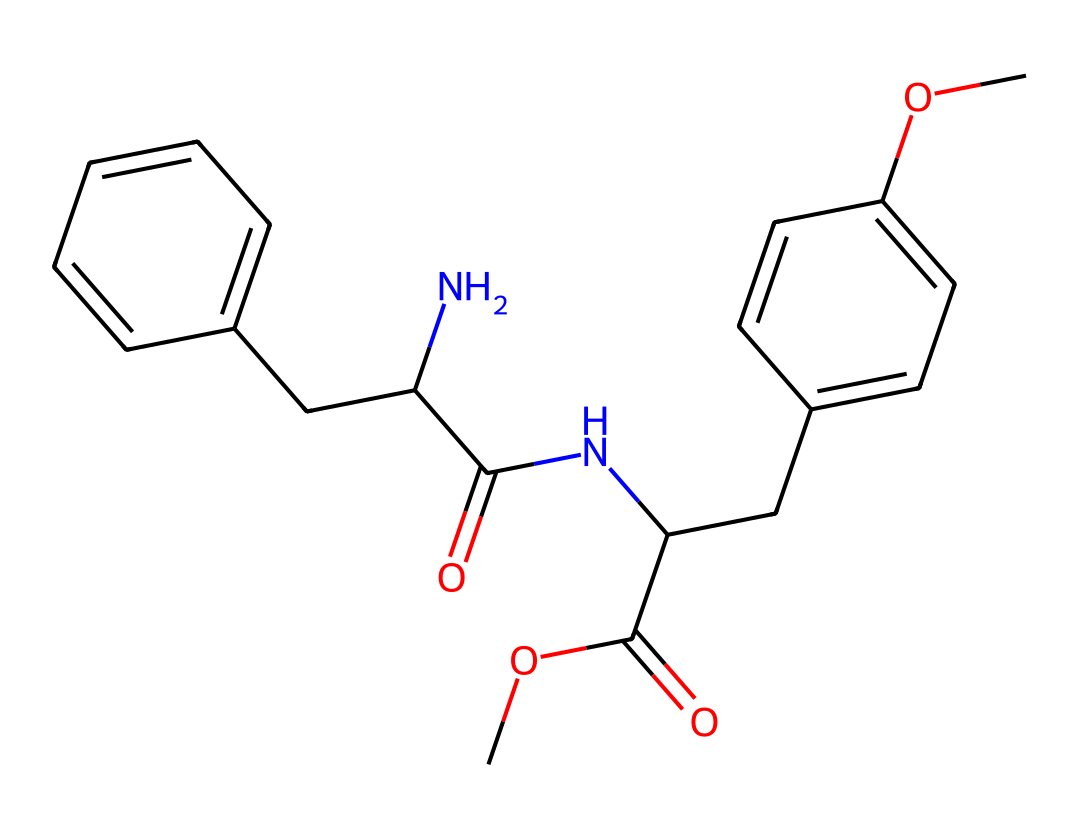What is the molecular formula of aspartame? To find the molecular formula, we can analyze the SMILES representation for each type of atom present. By counting carbon (C), hydrogen (H), nitrogen (N), and oxygen (O) atoms, we find 14 carbons, 18 hydrogens, 2 nitrogens, and 5 oxygens, resulting in the formula C14H18N2O5.
Answer: C14H18N2O5 How many rings are present in the structure of aspartame? In the provided SMILES, we need to look for any indications of cyclic structures. The notation with capital letters and corresponding numbering indicates cyclic compounds. Scanning through the chemical reveals two distinct benzene rings, making the total count two.
Answer: 2 What is the primary functional group in aspartame? By analyzing the SMILES, we find that aspartame contains amide (–CONH) and ester (–COOR) groups, however, the amide functional group plays a more significant role in its sweetness. Hence, the primary functional group associated with its sweetness is the amide group.
Answer: amide What is the role of aspartame in food products? As a food additive, aspartame serves as a low-calorie sweetener. It is utilized extensively in diet sodas and sugar-free products due to its ability to provide sweetness without the calories that sugar contains.
Answer: low-calorie sweetener What structural feature allows aspartame to mimic sugar's sweetness? The presence of specific functional groups and the arrangement of atoms within aspartame relate to its sweet taste. Particularly, the combination of the methyl ester and aromatic rings creates a structure that activates sweet taste receptors similarly to sugar.
Answer: methyl ester and aromatic rings 